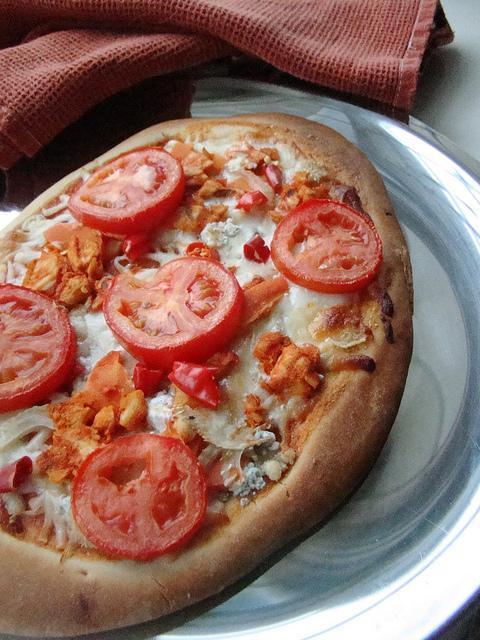How many birds are there?
Give a very brief answer. 0. 